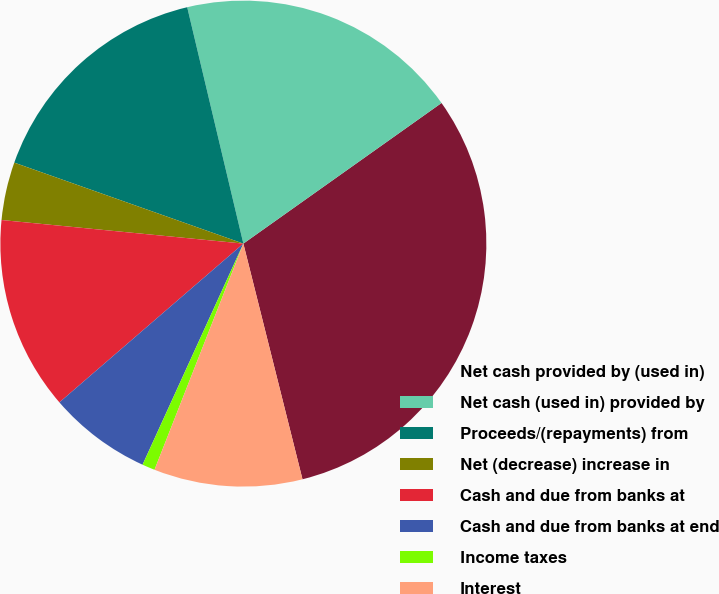<chart> <loc_0><loc_0><loc_500><loc_500><pie_chart><fcel>Net cash provided by (used in)<fcel>Net cash (used in) provided by<fcel>Proceeds/(repayments) from<fcel>Net (decrease) increase in<fcel>Cash and due from banks at<fcel>Cash and due from banks at end<fcel>Income taxes<fcel>Interest<nl><fcel>30.91%<fcel>18.89%<fcel>15.88%<fcel>3.86%<fcel>12.88%<fcel>6.86%<fcel>0.85%<fcel>9.87%<nl></chart> 